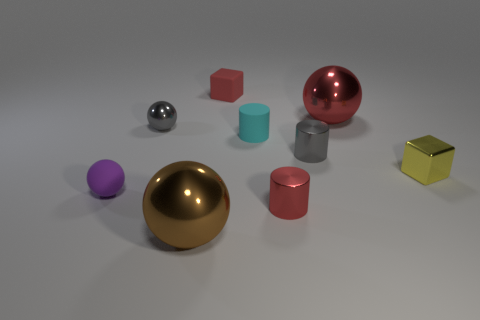Subtract 1 cylinders. How many cylinders are left? 2 Subtract all shiny balls. How many balls are left? 1 Subtract all gray balls. How many balls are left? 3 Add 1 tiny cyan shiny things. How many objects exist? 10 Subtract all green balls. Subtract all gray cylinders. How many balls are left? 4 Subtract all cylinders. How many objects are left? 6 Subtract 0 blue cylinders. How many objects are left? 9 Subtract all tiny cyan rubber objects. Subtract all brown spheres. How many objects are left? 7 Add 6 tiny yellow metallic things. How many tiny yellow metallic things are left? 7 Add 4 purple matte cubes. How many purple matte cubes exist? 4 